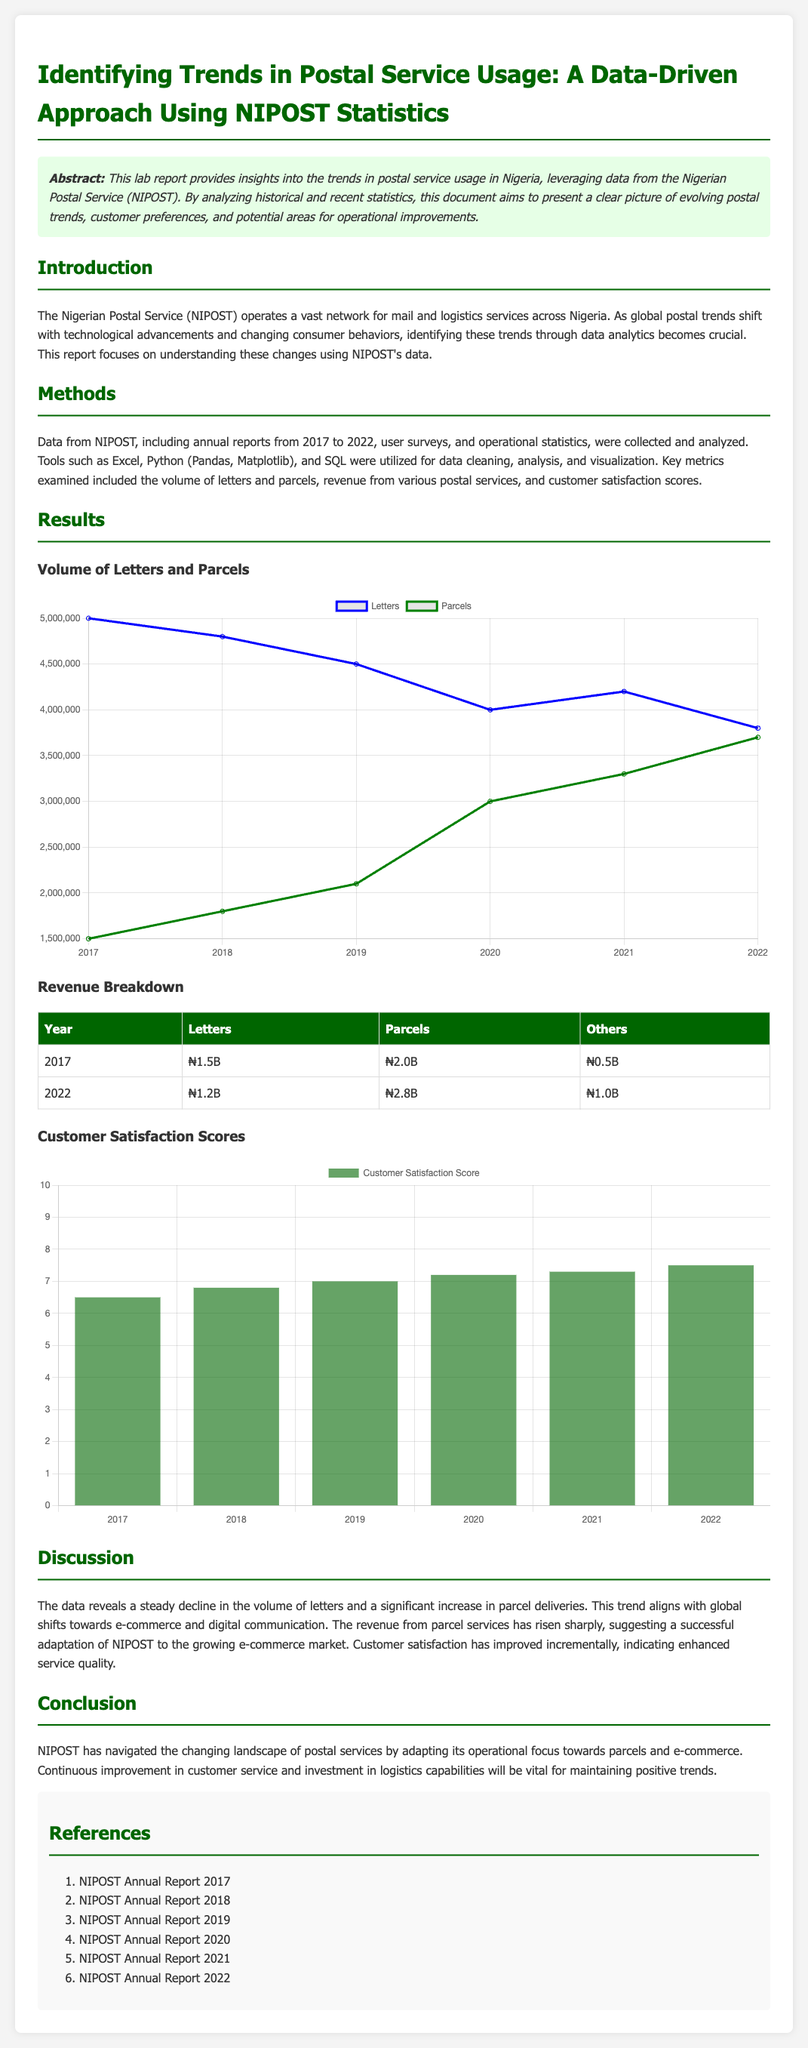What years are covered in the analysis? The analysis covers the years from 2017 to 2022 as mentioned in the document.
Answer: 2017 to 2022 What was the revenue from letters in 2022? The revenue from letters in 2022 is explicitly stated in the revenue breakdown table.
Answer: ₦1.2B Which year had the highest customer satisfaction score? The highest customer satisfaction score can be found by comparing the scores listed for each year in the satisfaction chart.
Answer: 2022 What trend is observed in the volume of letters from 2017 to 2022? The document describes this trend in the results section regarding the volume of letters over the years.
Answer: Decline What is the purpose of the lab report? The purpose is summarized in the abstract section, focusing on trends in postal service usage.
Answer: Identifying trends What type of data analysis tools were used in this report? The methods section lists various tools utilized in the analysis, providing insight into the analytical approach.
Answer: Excel, Python, SQL What has increased sharply according to the results? The report discusses different revenue sources and highlights which one has increased notably.
Answer: Parcel services What is indicated by the data regarding customer satisfaction? The discussion section analyzes the trends in customer satisfaction scores over the years.
Answer: Improved incrementally 